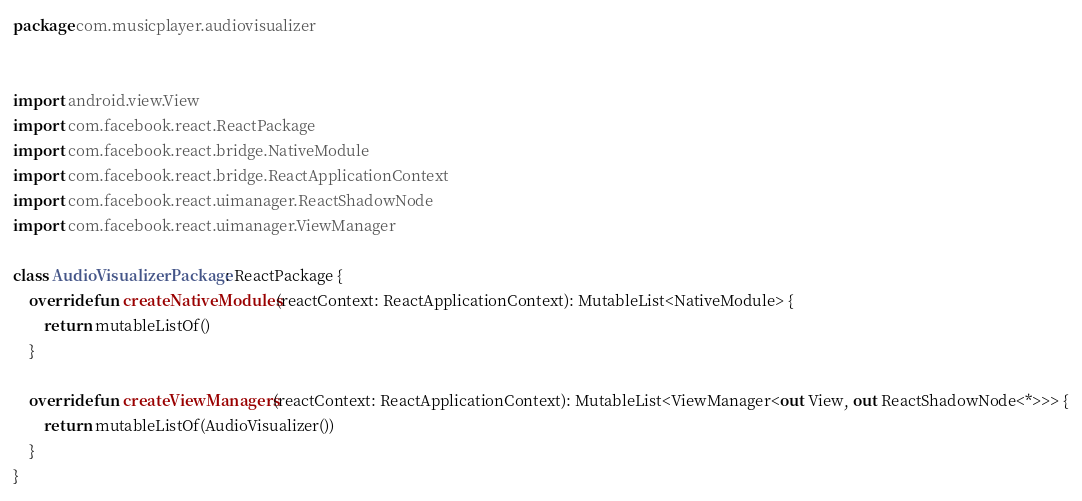Convert code to text. <code><loc_0><loc_0><loc_500><loc_500><_Kotlin_>package com.musicplayer.audiovisualizer


import android.view.View
import com.facebook.react.ReactPackage
import com.facebook.react.bridge.NativeModule
import com.facebook.react.bridge.ReactApplicationContext
import com.facebook.react.uimanager.ReactShadowNode
import com.facebook.react.uimanager.ViewManager

class AudioVisualizerPackage: ReactPackage {
    override fun createNativeModules(reactContext: ReactApplicationContext): MutableList<NativeModule> {
        return mutableListOf()
    }

    override fun createViewManagers(reactContext: ReactApplicationContext): MutableList<ViewManager<out View, out ReactShadowNode<*>>> {
        return mutableListOf(AudioVisualizer())
    }
}</code> 